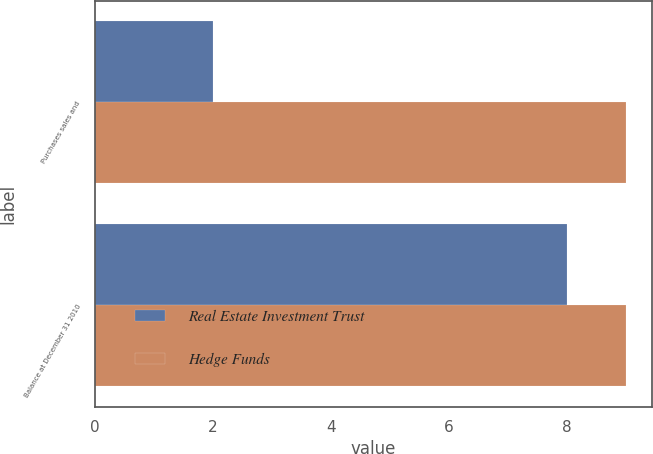Convert chart to OTSL. <chart><loc_0><loc_0><loc_500><loc_500><stacked_bar_chart><ecel><fcel>Purchases sales and<fcel>Balance at December 31 2010<nl><fcel>Real Estate Investment Trust<fcel>2<fcel>8<nl><fcel>Hedge Funds<fcel>9<fcel>9<nl></chart> 